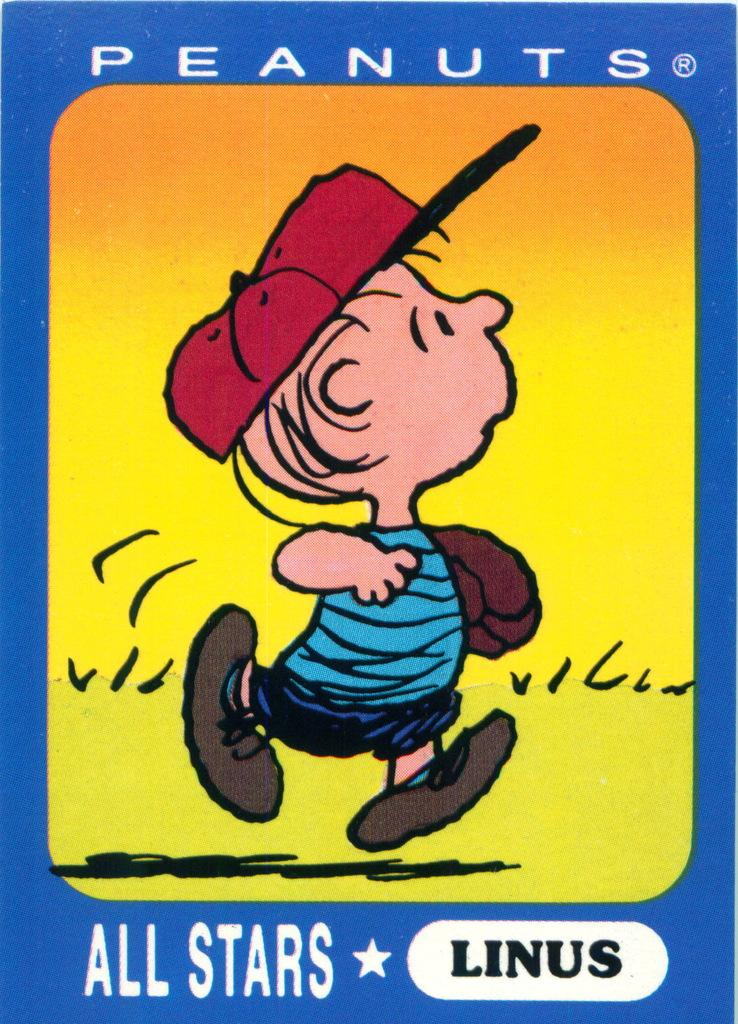What type of image is being described? The image is a poster. What is depicted on the poster? There is an animated person on the poster. Are there any words or phrases on the poster? Yes, there is text written on the poster. How many fangs can be seen on the animated person in the poster? There are no fangs visible on the animated person in the poster. What type of operation is being performed by the crowd in the poster? There is no crowd or operation depicted in the poster; it features an animated person and text. 